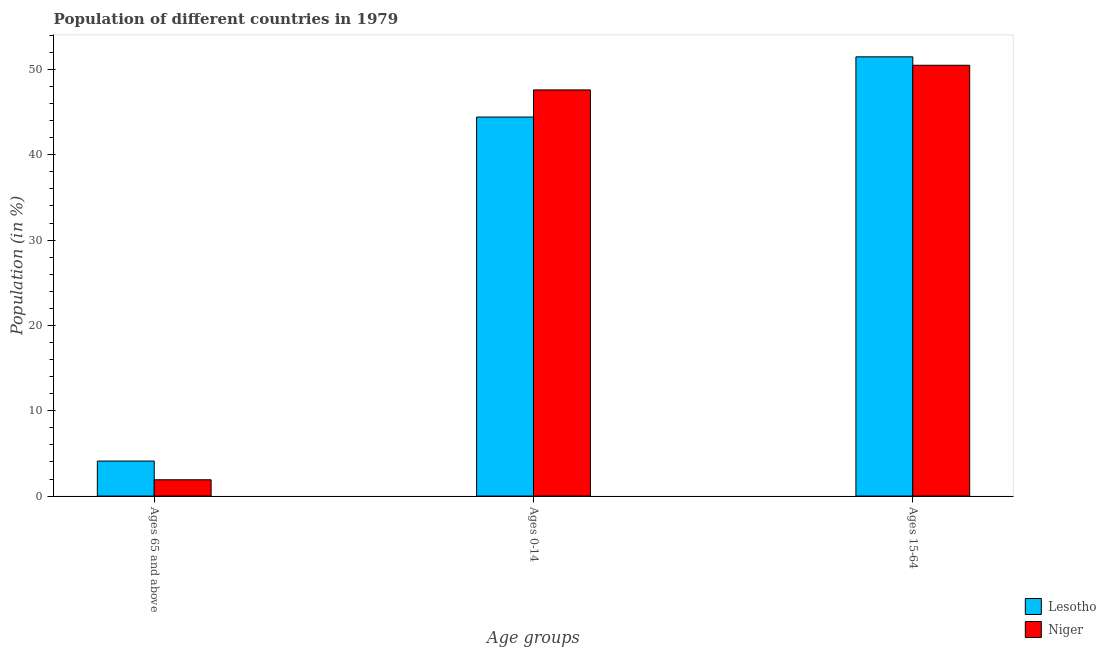Are the number of bars per tick equal to the number of legend labels?
Keep it short and to the point. Yes. How many bars are there on the 1st tick from the left?
Give a very brief answer. 2. What is the label of the 3rd group of bars from the left?
Your answer should be very brief. Ages 15-64. What is the percentage of population within the age-group 15-64 in Lesotho?
Give a very brief answer. 51.48. Across all countries, what is the maximum percentage of population within the age-group 0-14?
Your answer should be very brief. 47.6. Across all countries, what is the minimum percentage of population within the age-group 0-14?
Your answer should be compact. 44.42. In which country was the percentage of population within the age-group 15-64 maximum?
Ensure brevity in your answer.  Lesotho. In which country was the percentage of population within the age-group of 65 and above minimum?
Your answer should be compact. Niger. What is the total percentage of population within the age-group of 65 and above in the graph?
Offer a terse response. 6.01. What is the difference between the percentage of population within the age-group 15-64 in Niger and that in Lesotho?
Ensure brevity in your answer.  -0.99. What is the difference between the percentage of population within the age-group 15-64 in Lesotho and the percentage of population within the age-group 0-14 in Niger?
Your answer should be compact. 3.88. What is the average percentage of population within the age-group 0-14 per country?
Your answer should be compact. 46.01. What is the difference between the percentage of population within the age-group 0-14 and percentage of population within the age-group 15-64 in Niger?
Offer a very short reply. -2.89. In how many countries, is the percentage of population within the age-group of 65 and above greater than 6 %?
Provide a succinct answer. 0. What is the ratio of the percentage of population within the age-group of 65 and above in Niger to that in Lesotho?
Offer a very short reply. 0.47. Is the percentage of population within the age-group 15-64 in Lesotho less than that in Niger?
Ensure brevity in your answer.  No. Is the difference between the percentage of population within the age-group of 65 and above in Lesotho and Niger greater than the difference between the percentage of population within the age-group 15-64 in Lesotho and Niger?
Make the answer very short. Yes. What is the difference between the highest and the second highest percentage of population within the age-group 15-64?
Keep it short and to the point. 0.99. What is the difference between the highest and the lowest percentage of population within the age-group 0-14?
Provide a short and direct response. 3.18. Is the sum of the percentage of population within the age-group 15-64 in Lesotho and Niger greater than the maximum percentage of population within the age-group of 65 and above across all countries?
Keep it short and to the point. Yes. What does the 1st bar from the left in Ages 0-14 represents?
Make the answer very short. Lesotho. What does the 1st bar from the right in Ages 0-14 represents?
Your answer should be compact. Niger. Is it the case that in every country, the sum of the percentage of population within the age-group of 65 and above and percentage of population within the age-group 0-14 is greater than the percentage of population within the age-group 15-64?
Give a very brief answer. No. How many bars are there?
Your response must be concise. 6. How many countries are there in the graph?
Give a very brief answer. 2. Are the values on the major ticks of Y-axis written in scientific E-notation?
Offer a terse response. No. Does the graph contain grids?
Keep it short and to the point. No. How are the legend labels stacked?
Provide a short and direct response. Vertical. What is the title of the graph?
Offer a very short reply. Population of different countries in 1979. Does "Nigeria" appear as one of the legend labels in the graph?
Your answer should be compact. No. What is the label or title of the X-axis?
Offer a very short reply. Age groups. What is the label or title of the Y-axis?
Your answer should be very brief. Population (in %). What is the Population (in %) in Lesotho in Ages 65 and above?
Ensure brevity in your answer.  4.1. What is the Population (in %) of Niger in Ages 65 and above?
Provide a short and direct response. 1.91. What is the Population (in %) of Lesotho in Ages 0-14?
Provide a short and direct response. 44.42. What is the Population (in %) of Niger in Ages 0-14?
Offer a very short reply. 47.6. What is the Population (in %) of Lesotho in Ages 15-64?
Give a very brief answer. 51.48. What is the Population (in %) in Niger in Ages 15-64?
Provide a succinct answer. 50.49. Across all Age groups, what is the maximum Population (in %) of Lesotho?
Offer a very short reply. 51.48. Across all Age groups, what is the maximum Population (in %) of Niger?
Provide a short and direct response. 50.49. Across all Age groups, what is the minimum Population (in %) of Lesotho?
Your answer should be very brief. 4.1. Across all Age groups, what is the minimum Population (in %) in Niger?
Offer a very short reply. 1.91. What is the total Population (in %) in Lesotho in the graph?
Your answer should be very brief. 100. What is the total Population (in %) in Niger in the graph?
Your answer should be very brief. 100. What is the difference between the Population (in %) in Lesotho in Ages 65 and above and that in Ages 0-14?
Give a very brief answer. -40.32. What is the difference between the Population (in %) in Niger in Ages 65 and above and that in Ages 0-14?
Your answer should be very brief. -45.69. What is the difference between the Population (in %) in Lesotho in Ages 65 and above and that in Ages 15-64?
Offer a terse response. -47.37. What is the difference between the Population (in %) of Niger in Ages 65 and above and that in Ages 15-64?
Provide a short and direct response. -48.58. What is the difference between the Population (in %) of Lesotho in Ages 0-14 and that in Ages 15-64?
Provide a short and direct response. -7.06. What is the difference between the Population (in %) in Niger in Ages 0-14 and that in Ages 15-64?
Make the answer very short. -2.89. What is the difference between the Population (in %) of Lesotho in Ages 65 and above and the Population (in %) of Niger in Ages 0-14?
Ensure brevity in your answer.  -43.5. What is the difference between the Population (in %) in Lesotho in Ages 65 and above and the Population (in %) in Niger in Ages 15-64?
Your answer should be compact. -46.39. What is the difference between the Population (in %) of Lesotho in Ages 0-14 and the Population (in %) of Niger in Ages 15-64?
Ensure brevity in your answer.  -6.07. What is the average Population (in %) of Lesotho per Age groups?
Your response must be concise. 33.33. What is the average Population (in %) of Niger per Age groups?
Provide a succinct answer. 33.33. What is the difference between the Population (in %) of Lesotho and Population (in %) of Niger in Ages 65 and above?
Your answer should be compact. 2.19. What is the difference between the Population (in %) of Lesotho and Population (in %) of Niger in Ages 0-14?
Make the answer very short. -3.18. What is the difference between the Population (in %) of Lesotho and Population (in %) of Niger in Ages 15-64?
Provide a succinct answer. 0.99. What is the ratio of the Population (in %) of Lesotho in Ages 65 and above to that in Ages 0-14?
Give a very brief answer. 0.09. What is the ratio of the Population (in %) of Niger in Ages 65 and above to that in Ages 0-14?
Offer a very short reply. 0.04. What is the ratio of the Population (in %) in Lesotho in Ages 65 and above to that in Ages 15-64?
Make the answer very short. 0.08. What is the ratio of the Population (in %) in Niger in Ages 65 and above to that in Ages 15-64?
Make the answer very short. 0.04. What is the ratio of the Population (in %) in Lesotho in Ages 0-14 to that in Ages 15-64?
Provide a short and direct response. 0.86. What is the ratio of the Population (in %) in Niger in Ages 0-14 to that in Ages 15-64?
Your response must be concise. 0.94. What is the difference between the highest and the second highest Population (in %) of Lesotho?
Your answer should be compact. 7.06. What is the difference between the highest and the second highest Population (in %) in Niger?
Make the answer very short. 2.89. What is the difference between the highest and the lowest Population (in %) of Lesotho?
Provide a short and direct response. 47.37. What is the difference between the highest and the lowest Population (in %) in Niger?
Ensure brevity in your answer.  48.58. 